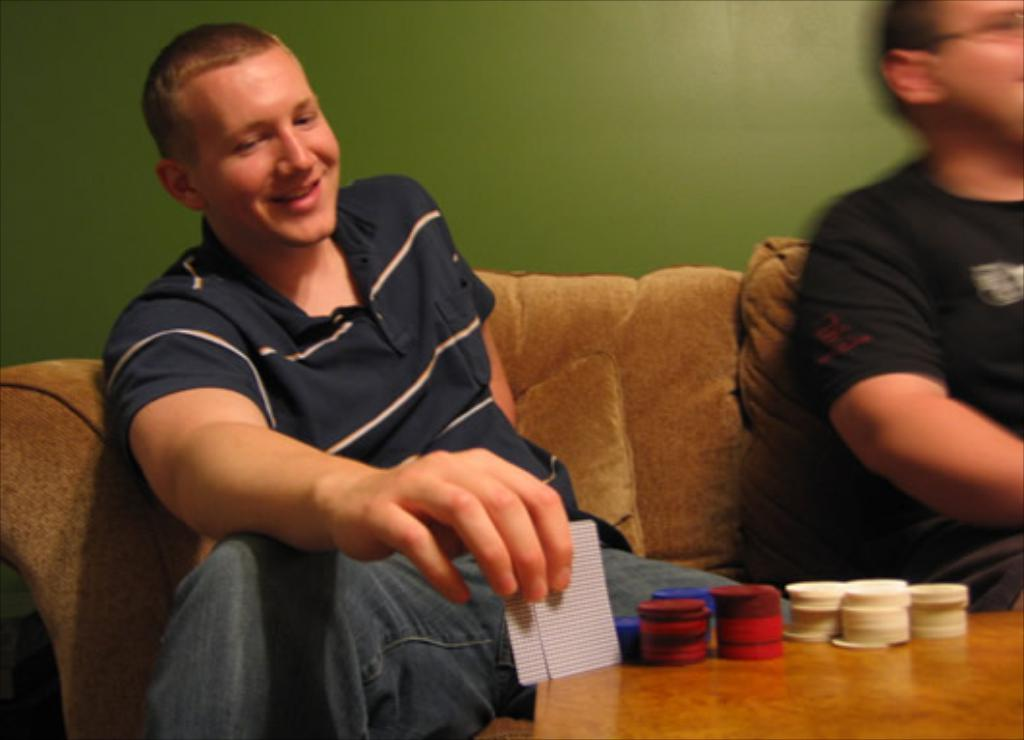How many people are sitting on the sofa in the image? There are two persons sitting on the sofa in the image. What objects can be seen on the table in the image? Coins and cards are visible on the table in the image. What is visible in the background of the image? There is a wall visible in the background of the image. What type of match is being played in the image? There is no match being played in the image; it only shows two persons sitting on a sofa and objects on a table. 